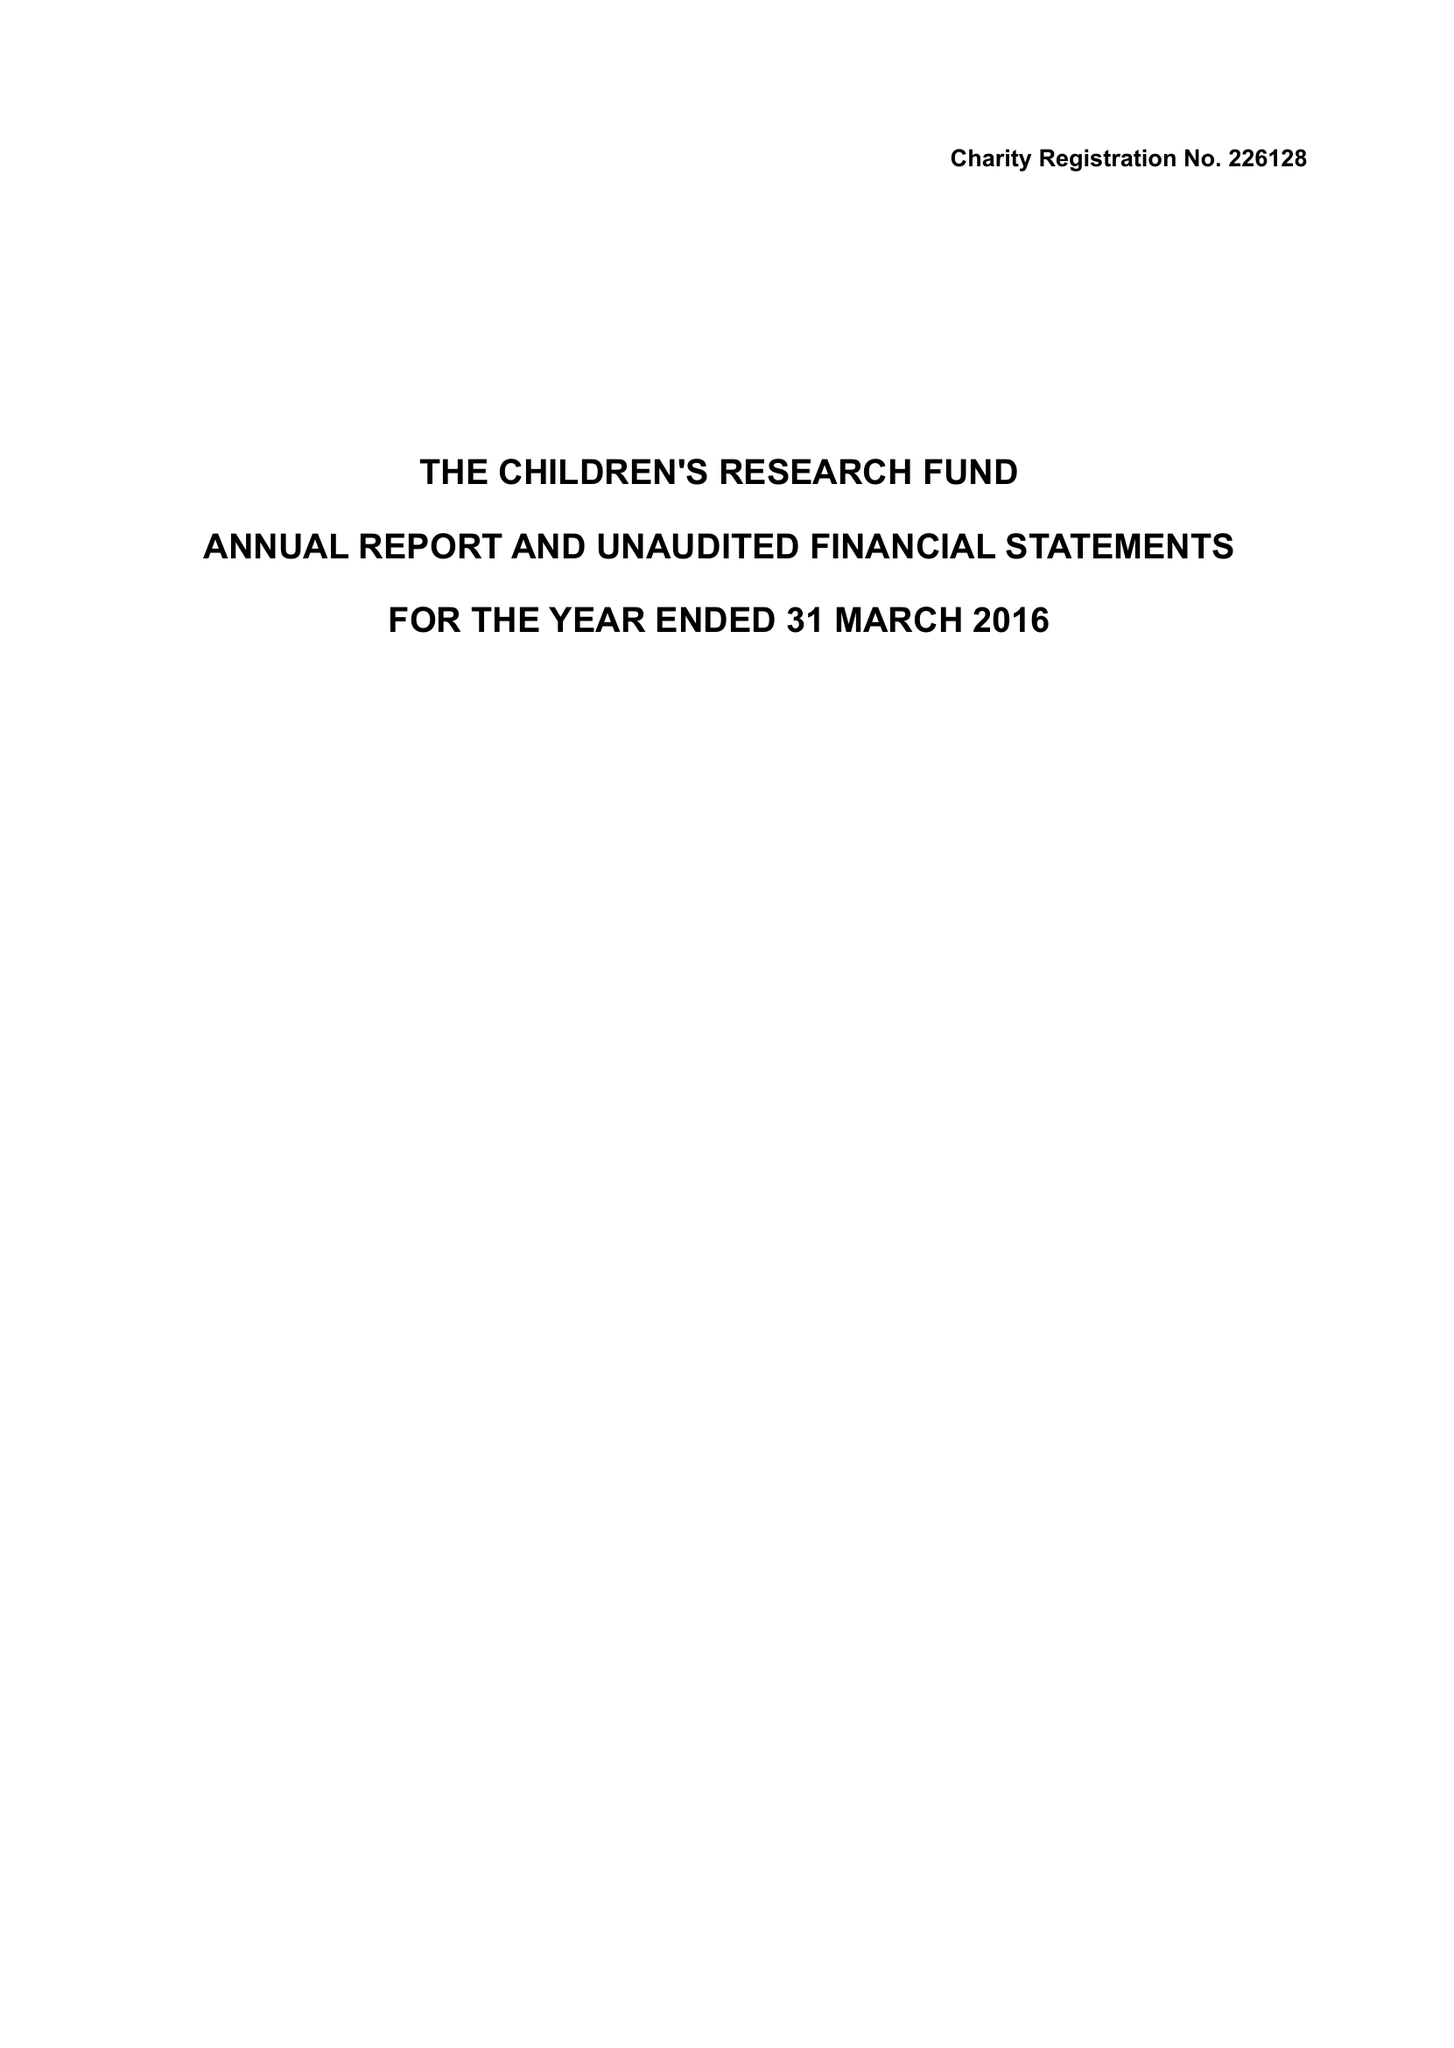What is the value for the charity_number?
Answer the question using a single word or phrase. 226128 